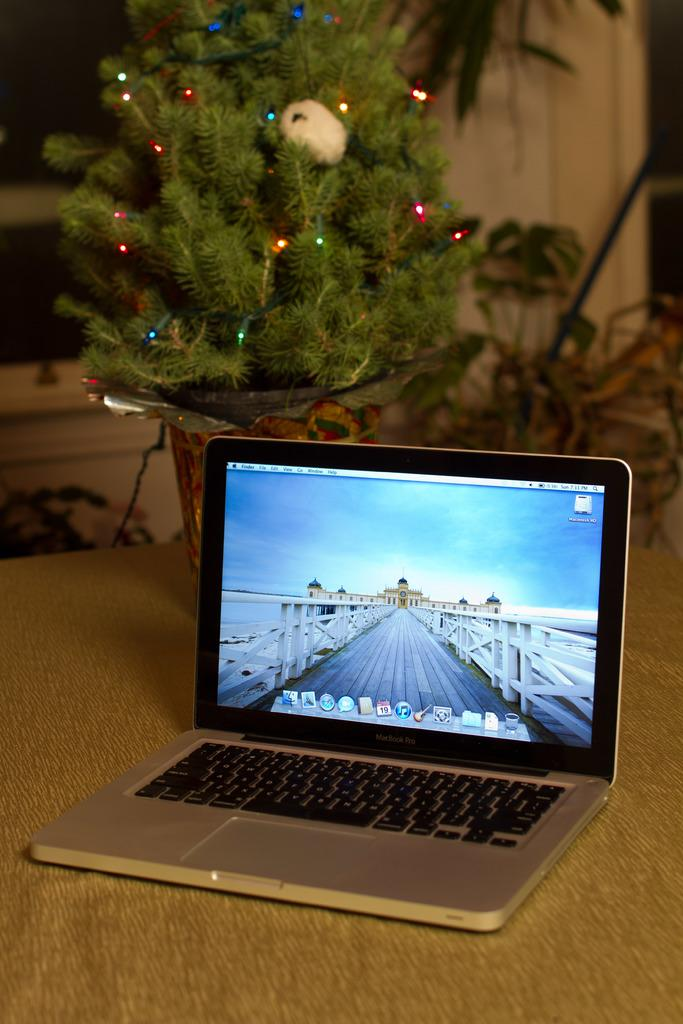What is the main piece of furniture in the image? There is a table in the image. What is placed on the table? There is a laptop and a houseplant on the table. How is the houseplant decorated? The houseplant is decorated with lights. What can be seen in the background of the image? There is a wall and plants visible in the background. What type of feather can be seen floating near the laptop in the image? There is no feather present in the image; it only features a table, laptop, houseplant, and background elements. 